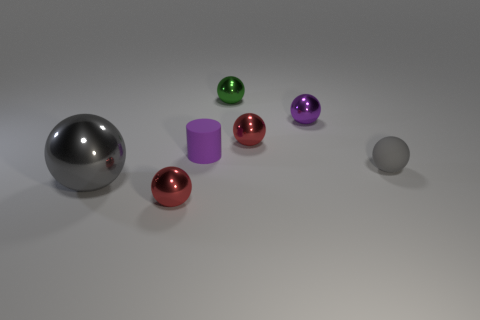Are there any other things that are the same color as the big shiny sphere? Indeed, there is a smaller sphere to the right that shares the same silvery color as the large, shiny sphere on the left. 